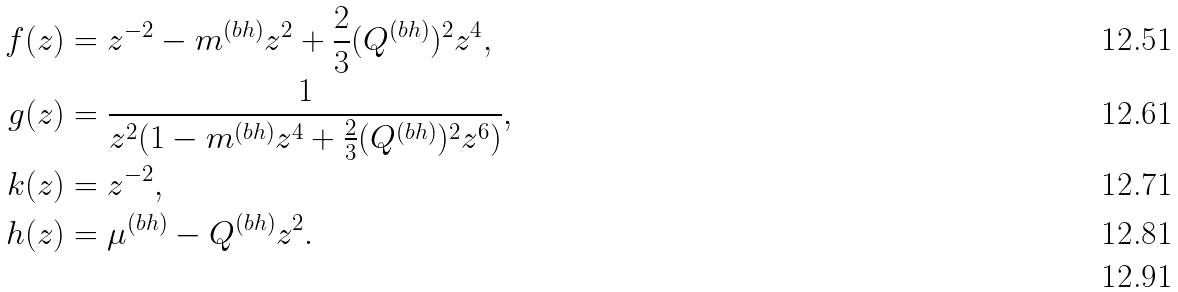<formula> <loc_0><loc_0><loc_500><loc_500>f ( z ) & = z ^ { - 2 } - m ^ { ( b h ) } z ^ { 2 } + \frac { 2 } { 3 } ( Q ^ { ( b h ) } ) ^ { 2 } z ^ { 4 } , \\ g ( z ) & = \frac { 1 } { z ^ { 2 } ( 1 - m ^ { ( b h ) } z ^ { 4 } + \frac { 2 } { 3 } ( Q ^ { ( b h ) } ) ^ { 2 } z ^ { 6 } ) } , \\ k ( z ) & = z ^ { - 2 } , \\ h ( z ) & = \mu ^ { ( b h ) } - Q ^ { ( b h ) } z ^ { 2 } . \\</formula> 